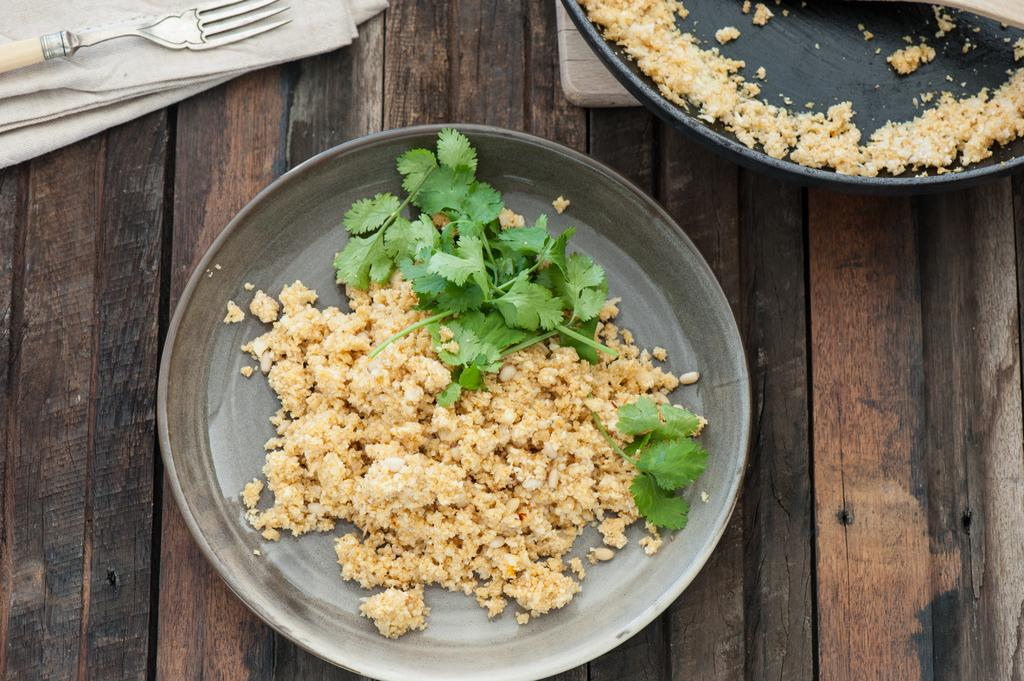What type of table is in the image? There is a wooden table in the image. How many napkins are on the table? There are two napkins on the table. What utensil is present on the table? There is a fork on the table. What is the tray used for in the image? The tray is used to hold a pan with a food item on the table. What is on the plate on the table? There is a food item and coriander leaves on the plate. What historical event is depicted in the art on the table? There is no art or historical event depicted on the table in the image. 